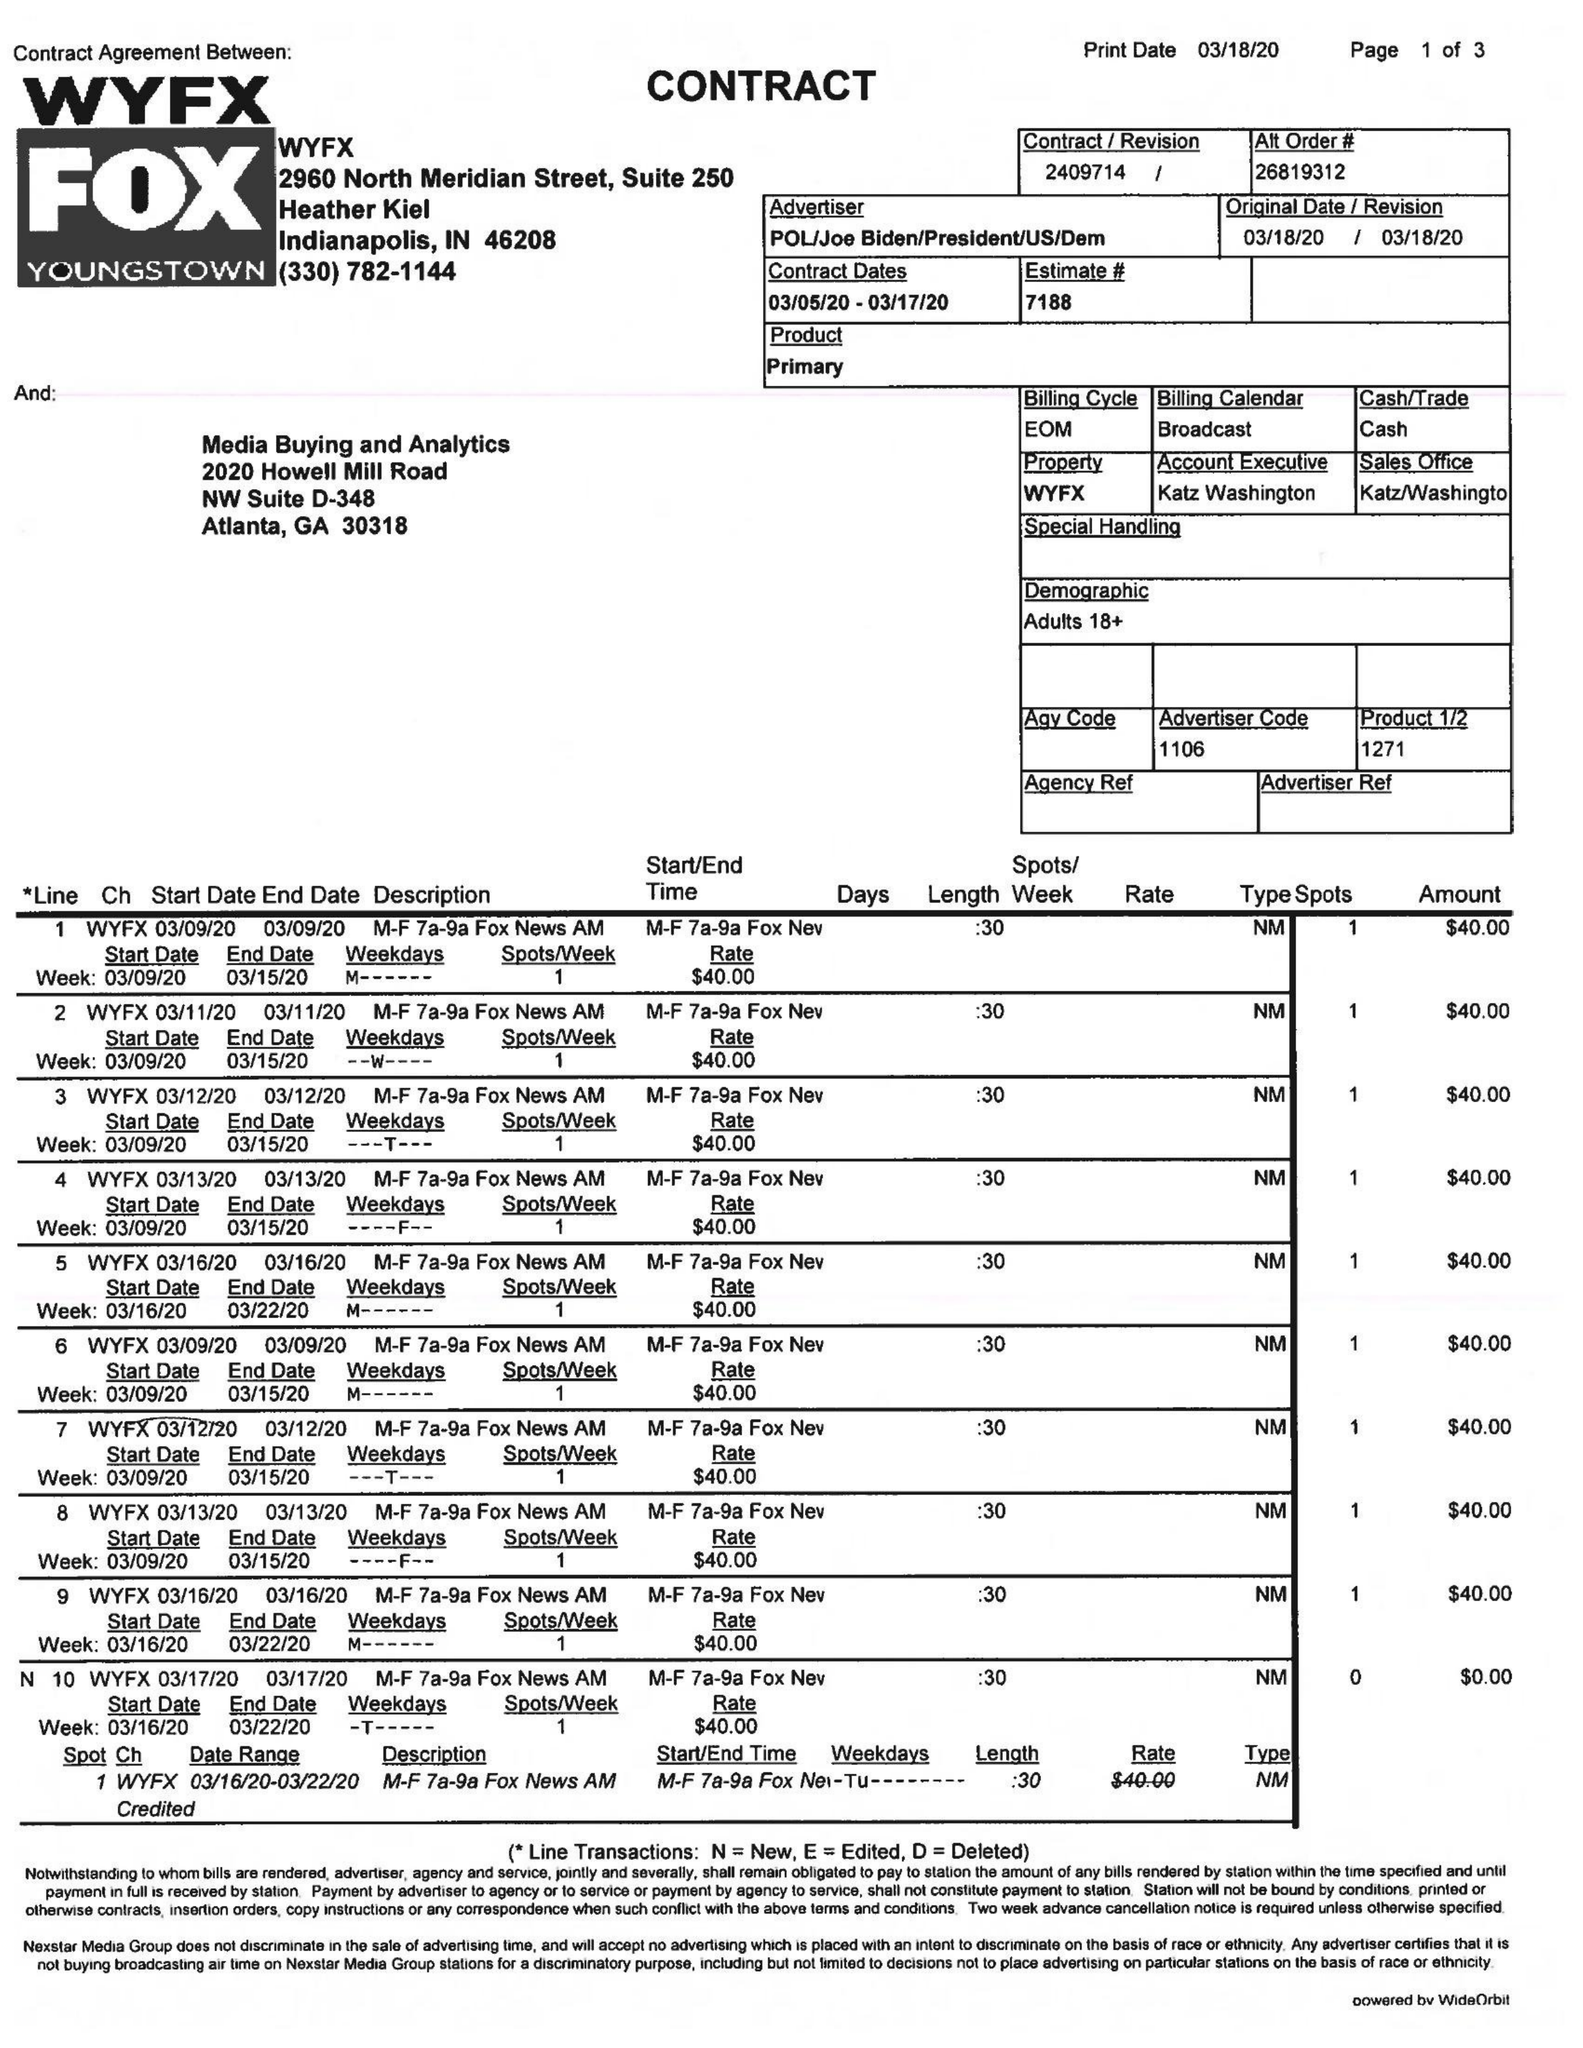What is the value for the advertiser?
Answer the question using a single word or phrase. POL/JOEBIDEN/PRESIDENT/US/DEM 